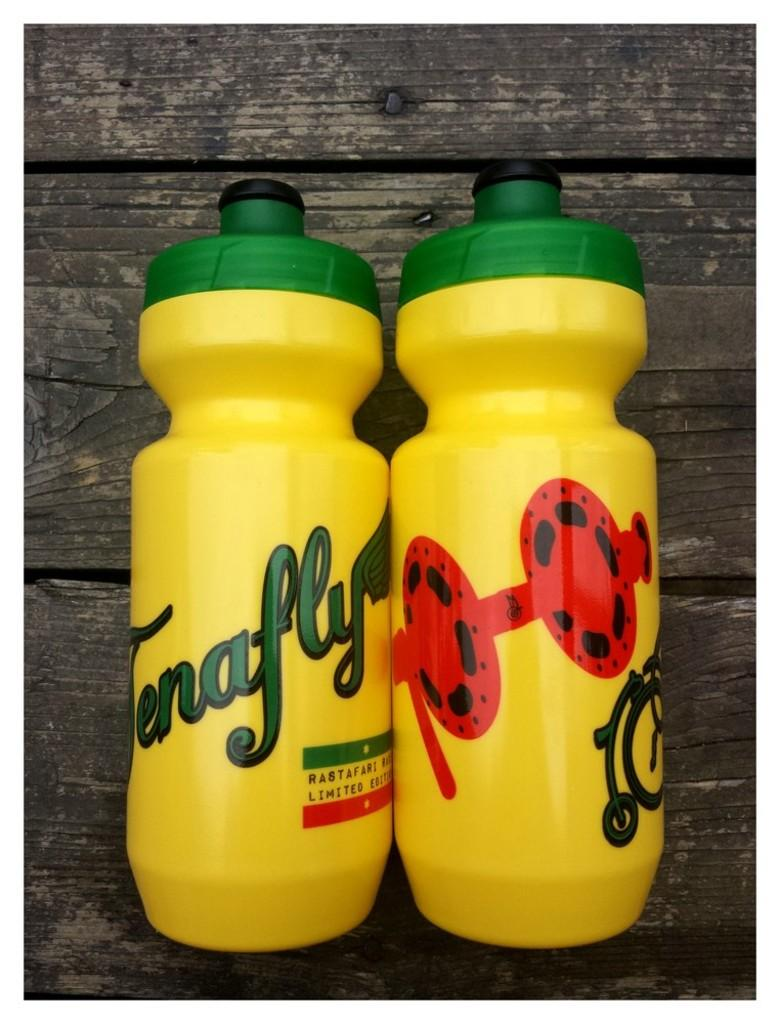<image>
Provide a brief description of the given image. Two limited edition Rastafari brand water bottles on top of a wooden table. 